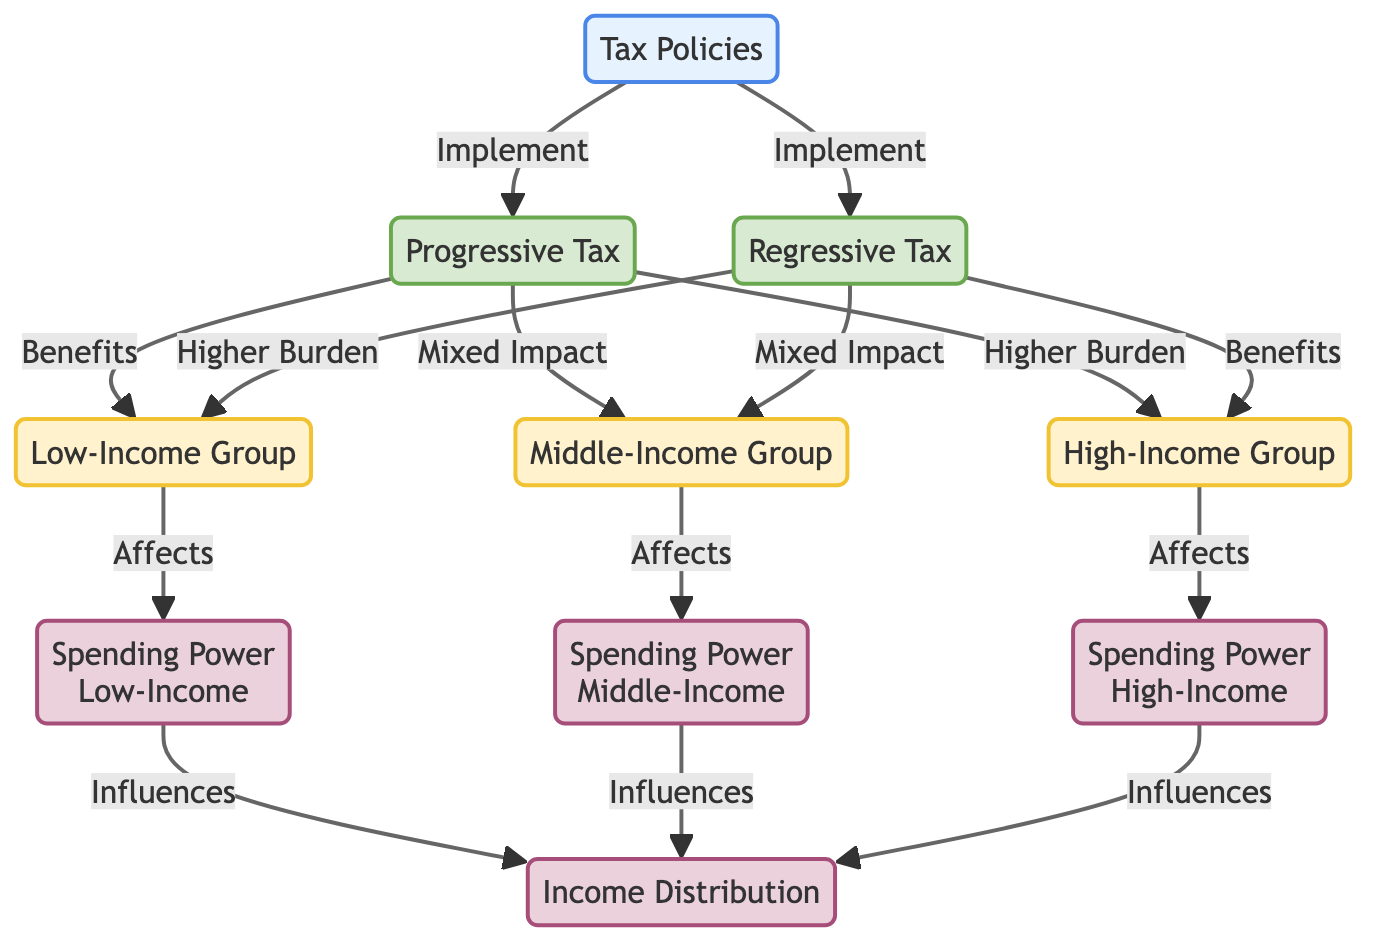What are the two types of tax policies shown in the diagram? The diagram displays two types of tax policies: Progressive Tax and Regressive Tax. These are explicitly represented as nodes connected to the Tax Policies node.
Answer: Progressive Tax, Regressive Tax Which income group benefits from the progressive tax? The diagram indicates that the Low-Income Group benefits from the Progressive Tax. This is shown by an arrow leading from the Progressive Tax node to the Low-Income Group node labeled "Benefits."
Answer: Low-Income Group What relationship is shown between spending power of low-income and income distribution? According to the diagram, the Spending Power of the Low-Income Group influences Income Distribution. This is represented by an arrow going from the Spending Power Low node to the Income Distribution node.
Answer: Influences How many income groups are affected by tax policies? The diagram includes three income groups: Low-Income Group, Middle-Income Group, and High-Income Group. These are represented as distinct nodes branching from the tax policy nodes.
Answer: Three Which tax policy has a higher burden on high-income individuals? The diagram shows that the Progressive Tax places a "Higher Burden" on the High-Income Group, which is indicated by an arrow from the Progressive Tax node to the High-Income Group node with the label "Higher Burden."
Answer: Progressive Tax What is the overall impact of regressive tax on low-income individuals? The diagram states that the Regressive Tax has a "Higher Burden" on the Low-Income Group, evidenced by the arrow leading from the Regressive Tax node to the Low-Income Group node labeled accordingly.
Answer: Higher Burden What effect does the spending power of the middle-income group have on income distribution? The diagram illustrates that the Spending Power of the Middle-Income Group influences Income Distribution, shown by an arrow originating from the Spending Power Middle node leading to the Income Distribution node.
Answer: Influences Which income group experiences mixed impact from both tax policies? The diagram indicates that the Middle-Income Group experiences a mixed impact from both the Progressive Tax and the Regressive Tax, as both policies show connections leading to the Middle-Income Group node with the label "Mixed Impact."
Answer: Middle-Income Group 